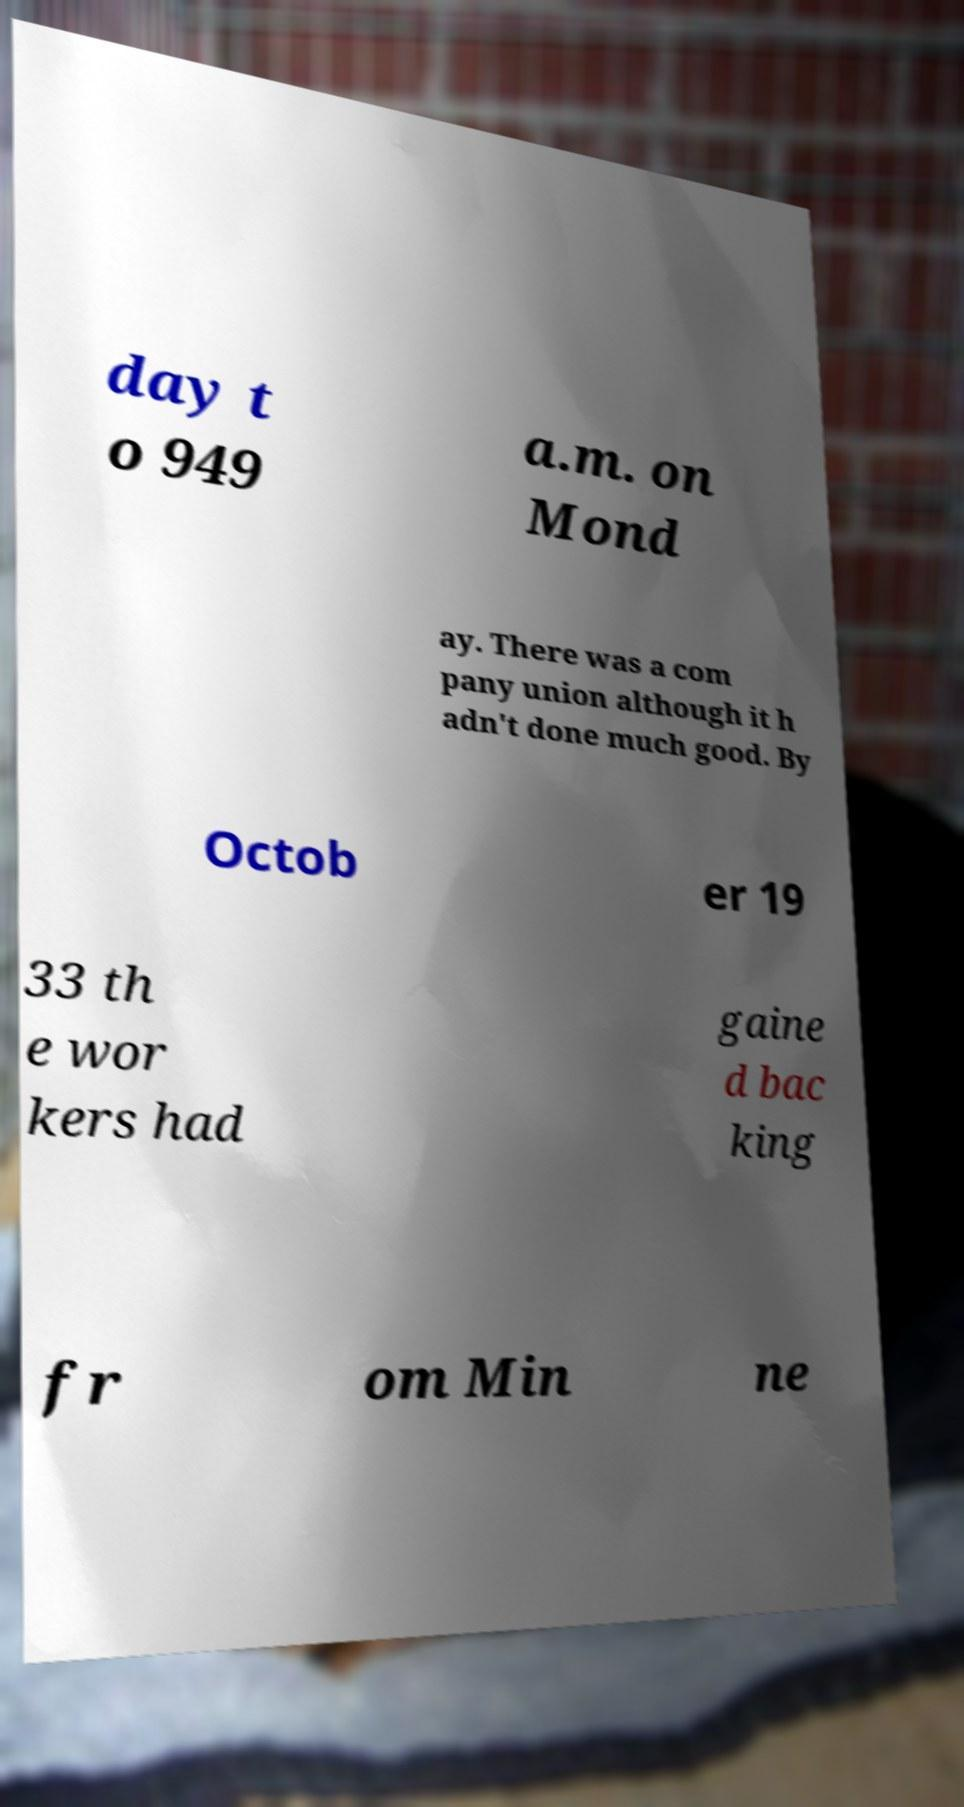I need the written content from this picture converted into text. Can you do that? day t o 949 a.m. on Mond ay. There was a com pany union although it h adn't done much good. By Octob er 19 33 th e wor kers had gaine d bac king fr om Min ne 